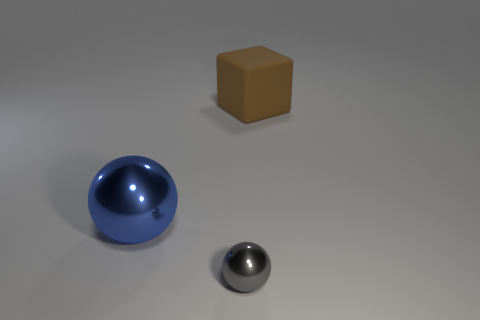Add 3 balls. How many objects exist? 6 Subtract all cubes. How many objects are left? 2 Add 2 big brown objects. How many big brown objects are left? 3 Add 2 metallic balls. How many metallic balls exist? 4 Subtract 0 purple blocks. How many objects are left? 3 Subtract all small green shiny balls. Subtract all large blue spheres. How many objects are left? 2 